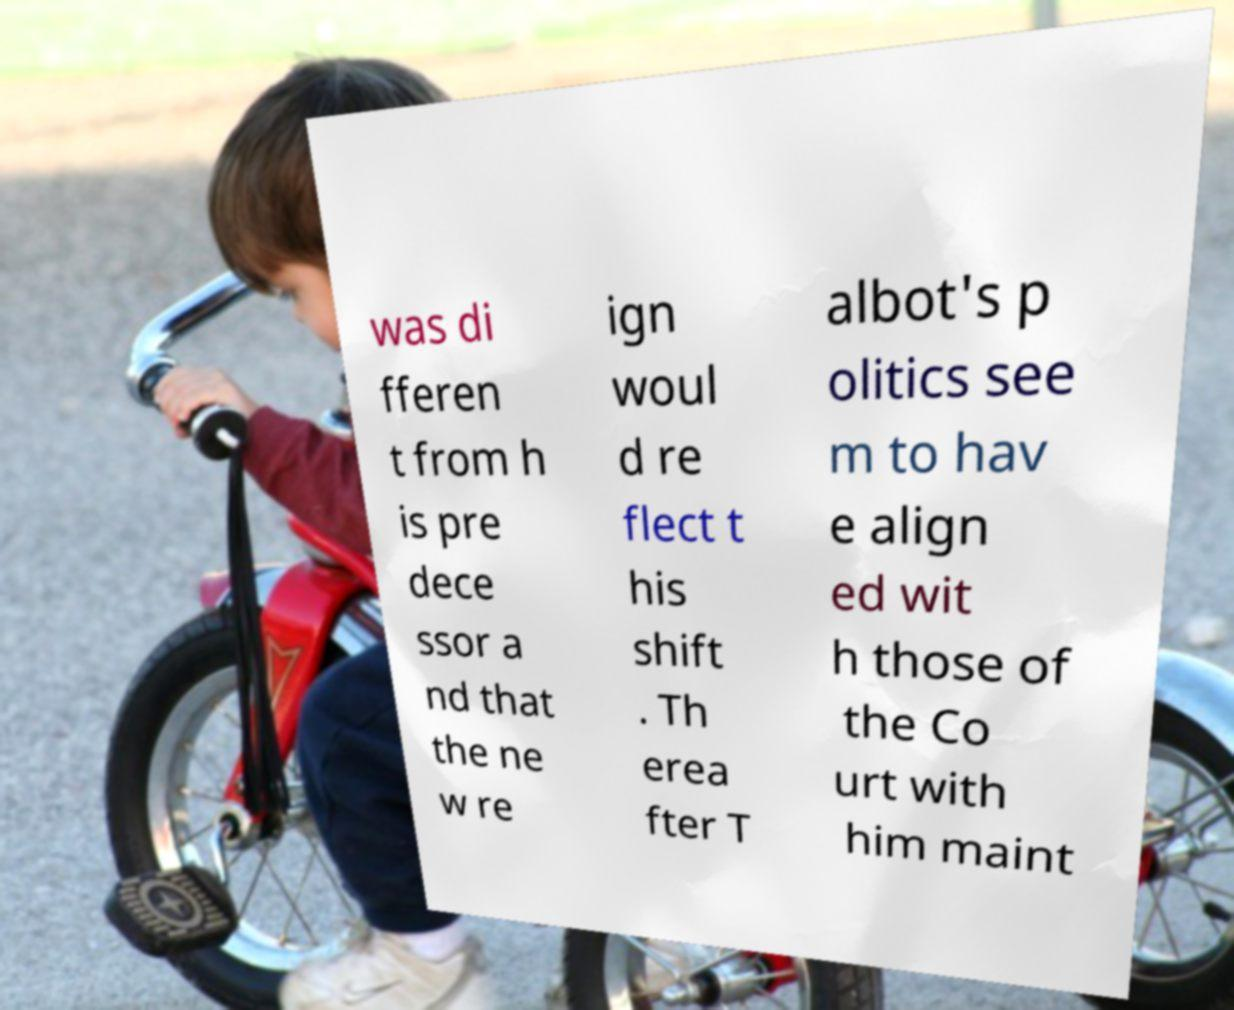For documentation purposes, I need the text within this image transcribed. Could you provide that? was di fferen t from h is pre dece ssor a nd that the ne w re ign woul d re flect t his shift . Th erea fter T albot's p olitics see m to hav e align ed wit h those of the Co urt with him maint 